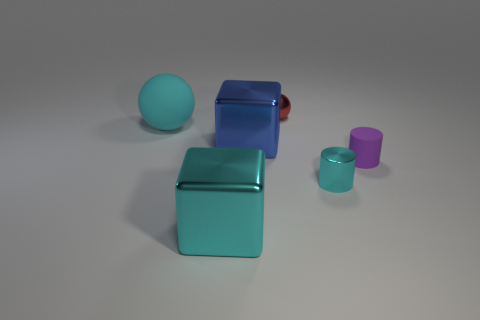The matte object that is the same color as the small metallic cylinder is what shape?
Make the answer very short. Sphere. What size is the cylinder that is the same color as the big matte thing?
Make the answer very short. Small. Is the size of the cyan shiny cylinder the same as the matte object right of the big blue block?
Your answer should be compact. Yes. There is a purple matte object that is the same shape as the tiny cyan metal thing; what is its size?
Make the answer very short. Small. Is the size of the rubber object on the left side of the red shiny object the same as the ball to the right of the cyan matte thing?
Your answer should be compact. No. How many big things are red things or purple things?
Provide a succinct answer. 0. What number of things are both to the left of the purple rubber object and right of the cyan block?
Keep it short and to the point. 3. Is the tiny purple object made of the same material as the small thing that is behind the small matte thing?
Your answer should be very brief. No. What number of blue objects are small matte cylinders or large shiny cubes?
Provide a succinct answer. 1. Are there any red metallic balls that have the same size as the cyan sphere?
Provide a succinct answer. No. 